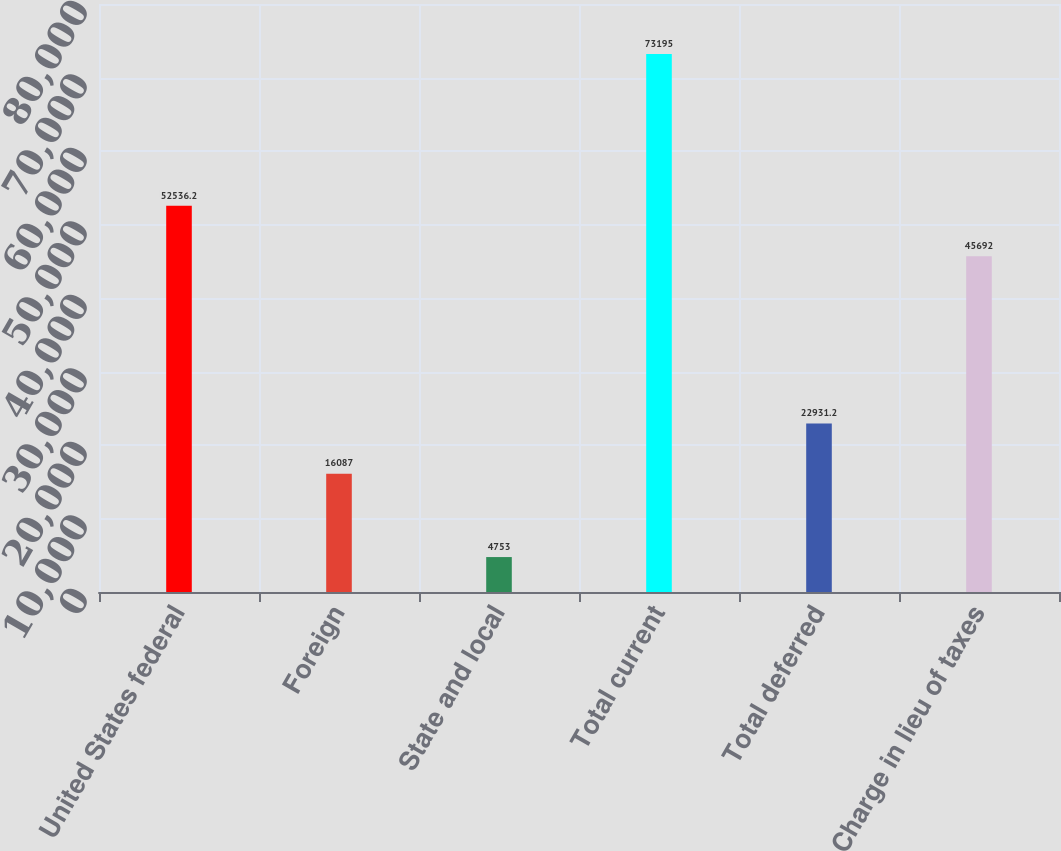Convert chart. <chart><loc_0><loc_0><loc_500><loc_500><bar_chart><fcel>United States federal<fcel>Foreign<fcel>State and local<fcel>Total current<fcel>Total deferred<fcel>Charge in lieu of taxes<nl><fcel>52536.2<fcel>16087<fcel>4753<fcel>73195<fcel>22931.2<fcel>45692<nl></chart> 